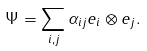<formula> <loc_0><loc_0><loc_500><loc_500>\Psi = \sum _ { i , j } \alpha _ { i j } e _ { i } \otimes e _ { j } .</formula> 